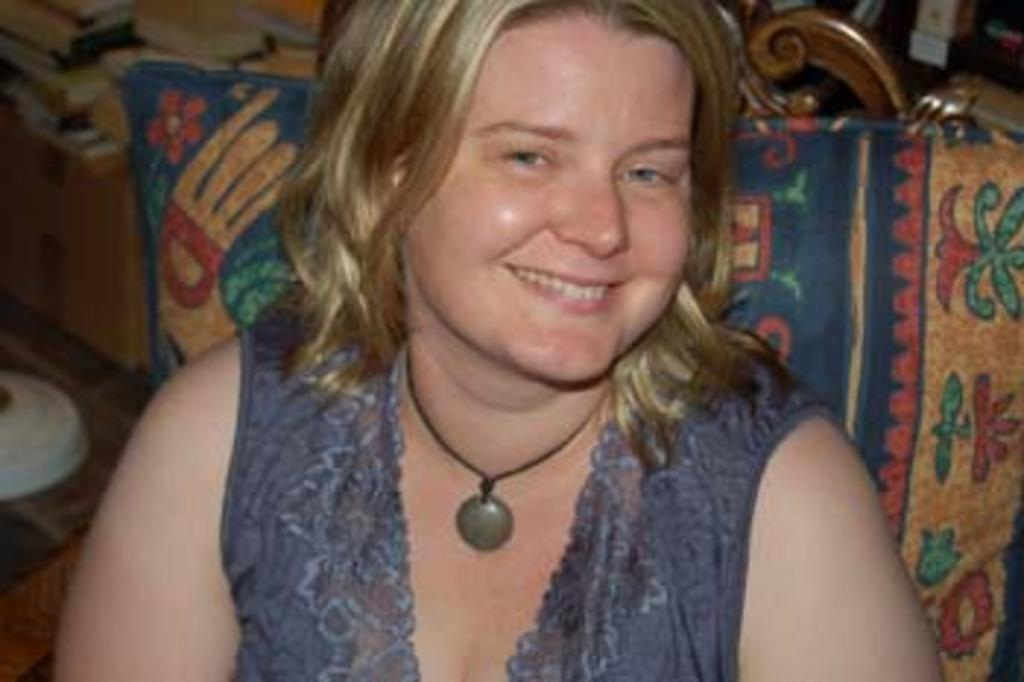What is the main subject of the image? The main subject of the image is a woman. Can you describe the woman's appearance? The woman is wearing clothes and a neck chain. What is the woman's facial expression? The woman is smiling. What can be seen behind the woman in the image? There are many other objects behind the woman. What type of surface is visible in the image? The image shows a floor. Are there any other items visible in the image? Yes, there are books in the image. How many ladybugs are crawling on the woman's neck chain in the image? There are no ladybugs present in the image, so it is not possible to determine how many might be crawling on the neck chain. 